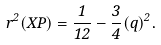<formula> <loc_0><loc_0><loc_500><loc_500>r ^ { 2 } ( X P ) = \frac { 1 } { 1 2 } - \frac { 3 } { 4 } ( q ) ^ { 2 } .</formula> 